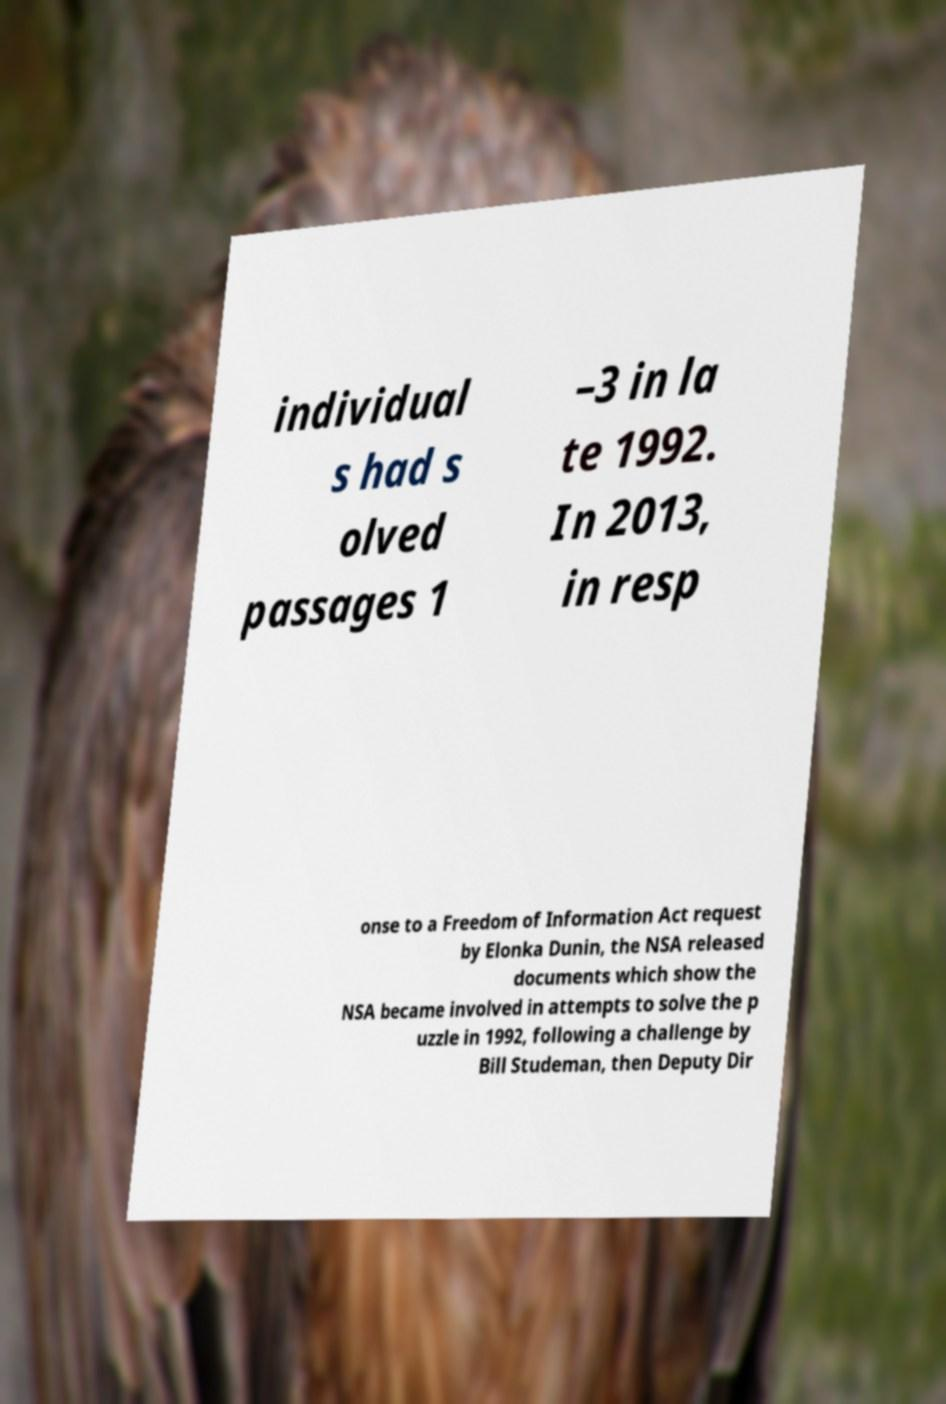Could you assist in decoding the text presented in this image and type it out clearly? individual s had s olved passages 1 –3 in la te 1992. In 2013, in resp onse to a Freedom of Information Act request by Elonka Dunin, the NSA released documents which show the NSA became involved in attempts to solve the p uzzle in 1992, following a challenge by Bill Studeman, then Deputy Dir 